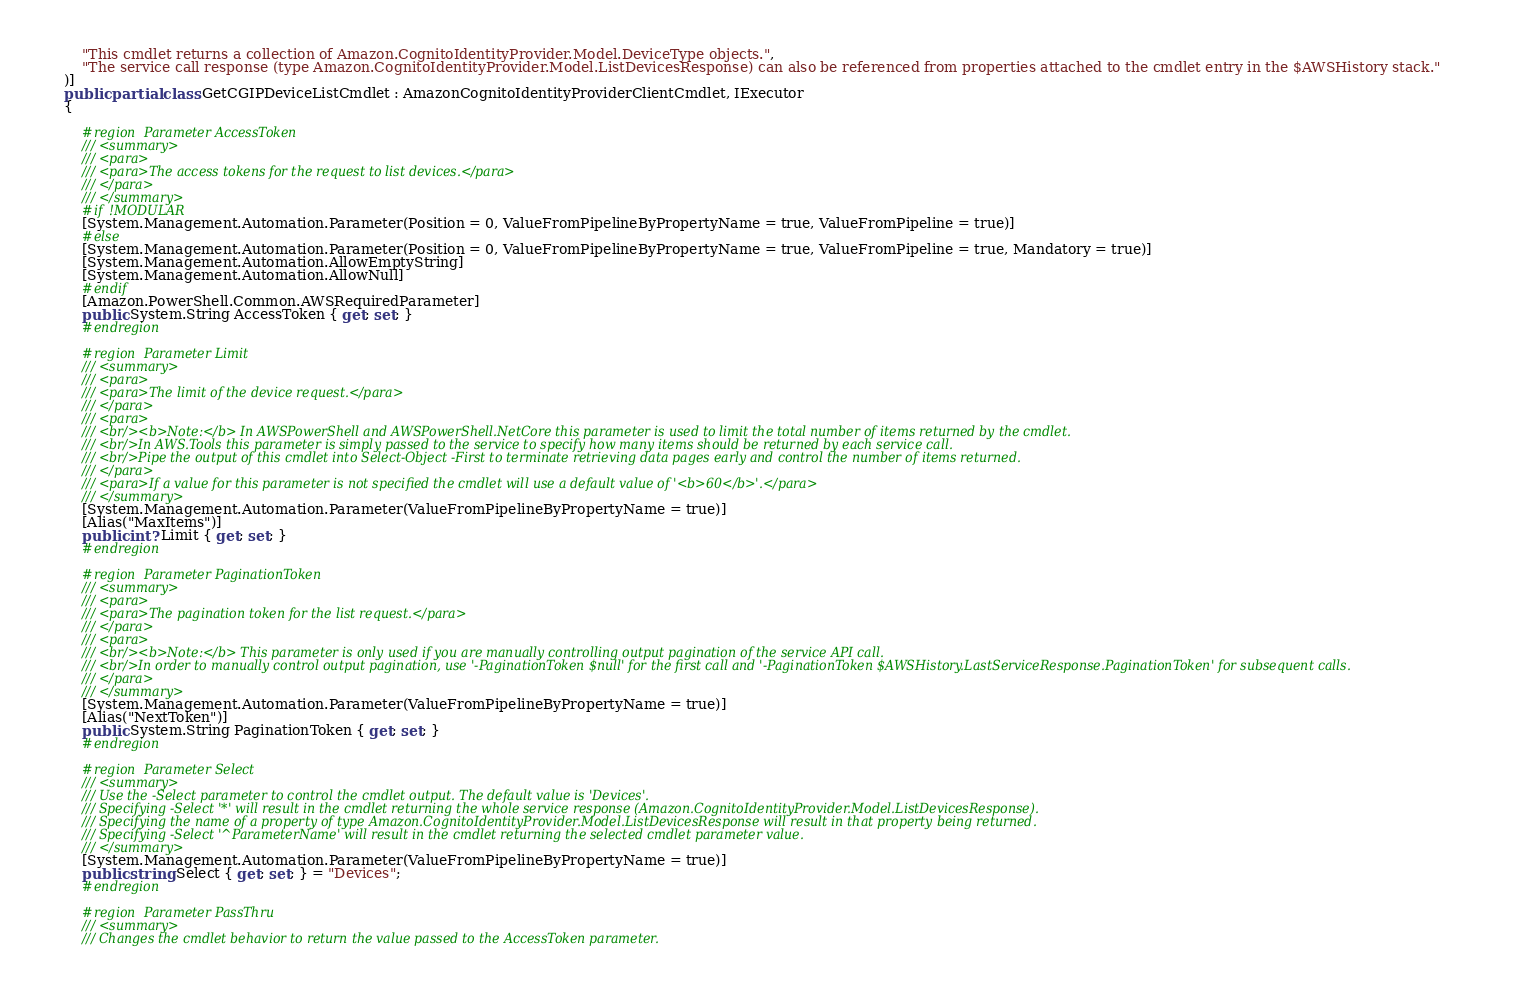Convert code to text. <code><loc_0><loc_0><loc_500><loc_500><_C#_>        "This cmdlet returns a collection of Amazon.CognitoIdentityProvider.Model.DeviceType objects.",
        "The service call response (type Amazon.CognitoIdentityProvider.Model.ListDevicesResponse) can also be referenced from properties attached to the cmdlet entry in the $AWSHistory stack."
    )]
    public partial class GetCGIPDeviceListCmdlet : AmazonCognitoIdentityProviderClientCmdlet, IExecutor
    {
        
        #region Parameter AccessToken
        /// <summary>
        /// <para>
        /// <para>The access tokens for the request to list devices.</para>
        /// </para>
        /// </summary>
        #if !MODULAR
        [System.Management.Automation.Parameter(Position = 0, ValueFromPipelineByPropertyName = true, ValueFromPipeline = true)]
        #else
        [System.Management.Automation.Parameter(Position = 0, ValueFromPipelineByPropertyName = true, ValueFromPipeline = true, Mandatory = true)]
        [System.Management.Automation.AllowEmptyString]
        [System.Management.Automation.AllowNull]
        #endif
        [Amazon.PowerShell.Common.AWSRequiredParameter]
        public System.String AccessToken { get; set; }
        #endregion
        
        #region Parameter Limit
        /// <summary>
        /// <para>
        /// <para>The limit of the device request.</para>
        /// </para>
        /// <para>
        /// <br/><b>Note:</b> In AWSPowerShell and AWSPowerShell.NetCore this parameter is used to limit the total number of items returned by the cmdlet.
        /// <br/>In AWS.Tools this parameter is simply passed to the service to specify how many items should be returned by each service call.
        /// <br/>Pipe the output of this cmdlet into Select-Object -First to terminate retrieving data pages early and control the number of items returned.
        /// </para>
        /// <para>If a value for this parameter is not specified the cmdlet will use a default value of '<b>60</b>'.</para>
        /// </summary>
        [System.Management.Automation.Parameter(ValueFromPipelineByPropertyName = true)]
        [Alias("MaxItems")]
        public int? Limit { get; set; }
        #endregion
        
        #region Parameter PaginationToken
        /// <summary>
        /// <para>
        /// <para>The pagination token for the list request.</para>
        /// </para>
        /// <para>
        /// <br/><b>Note:</b> This parameter is only used if you are manually controlling output pagination of the service API call.
        /// <br/>In order to manually control output pagination, use '-PaginationToken $null' for the first call and '-PaginationToken $AWSHistory.LastServiceResponse.PaginationToken' for subsequent calls.
        /// </para>
        /// </summary>
        [System.Management.Automation.Parameter(ValueFromPipelineByPropertyName = true)]
        [Alias("NextToken")]
        public System.String PaginationToken { get; set; }
        #endregion
        
        #region Parameter Select
        /// <summary>
        /// Use the -Select parameter to control the cmdlet output. The default value is 'Devices'.
        /// Specifying -Select '*' will result in the cmdlet returning the whole service response (Amazon.CognitoIdentityProvider.Model.ListDevicesResponse).
        /// Specifying the name of a property of type Amazon.CognitoIdentityProvider.Model.ListDevicesResponse will result in that property being returned.
        /// Specifying -Select '^ParameterName' will result in the cmdlet returning the selected cmdlet parameter value.
        /// </summary>
        [System.Management.Automation.Parameter(ValueFromPipelineByPropertyName = true)]
        public string Select { get; set; } = "Devices";
        #endregion
        
        #region Parameter PassThru
        /// <summary>
        /// Changes the cmdlet behavior to return the value passed to the AccessToken parameter.</code> 